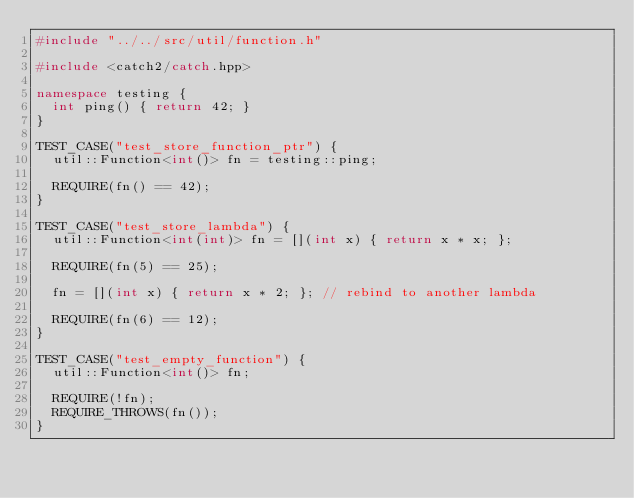Convert code to text. <code><loc_0><loc_0><loc_500><loc_500><_C++_>#include "../../src/util/function.h"

#include <catch2/catch.hpp>

namespace testing {
	int ping() { return 42; }
}

TEST_CASE("test_store_function_ptr") {
	util::Function<int()> fn = testing::ping;

	REQUIRE(fn() == 42);
}

TEST_CASE("test_store_lambda") {
	util::Function<int(int)> fn = [](int x) { return x * x; };

	REQUIRE(fn(5) == 25);

	fn = [](int x) { return x * 2; }; // rebind to another lambda

	REQUIRE(fn(6) == 12);
}

TEST_CASE("test_empty_function") {
	util::Function<int()> fn;

	REQUIRE(!fn);
	REQUIRE_THROWS(fn());
}
</code> 